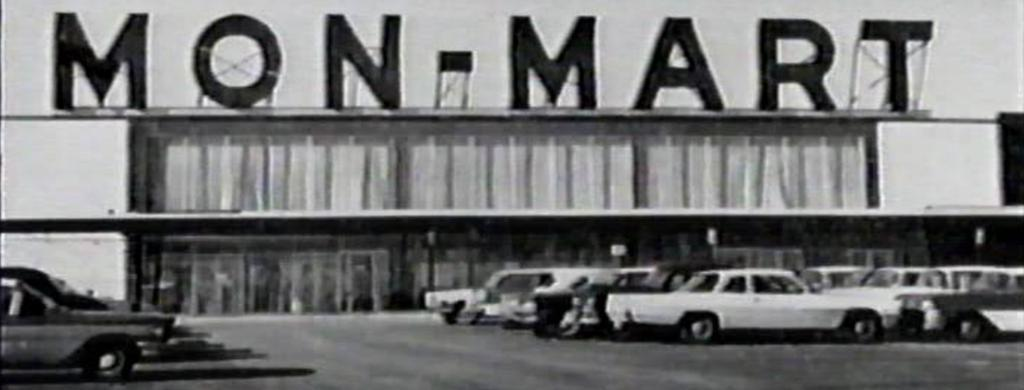What type of image is depicted in the picture? The image contains an old photograph. What can be seen in the photograph? The photograph features vintage cars. Where are the vintage cars located in the image? The vintage cars are parked in a parking area. What is visible in the background of the image? There is a big mall visible in the background of the image. What is written on the mall in the image? The mall has "Montmartre" written on it. How many prisoners are visible in the image? There are no prisoners or jail in the image; it features an old photograph of vintage cars parked in a parking area with a mall in the background. What type of bait is used to catch fish in the image? There is no fishing or bait present in the image. 